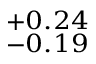Convert formula to latex. <formula><loc_0><loc_0><loc_500><loc_500>^ { + 0 . 2 4 } _ { - 0 . 1 9 }</formula> 